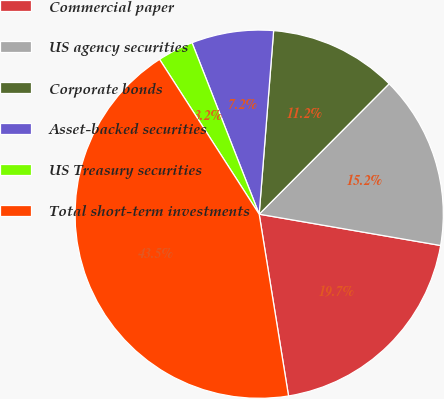Convert chart to OTSL. <chart><loc_0><loc_0><loc_500><loc_500><pie_chart><fcel>Commercial paper<fcel>US agency securities<fcel>Corporate bonds<fcel>Asset-backed securities<fcel>US Treasury securities<fcel>Total short-term investments<nl><fcel>19.73%<fcel>15.25%<fcel>11.22%<fcel>7.19%<fcel>3.16%<fcel>43.45%<nl></chart> 